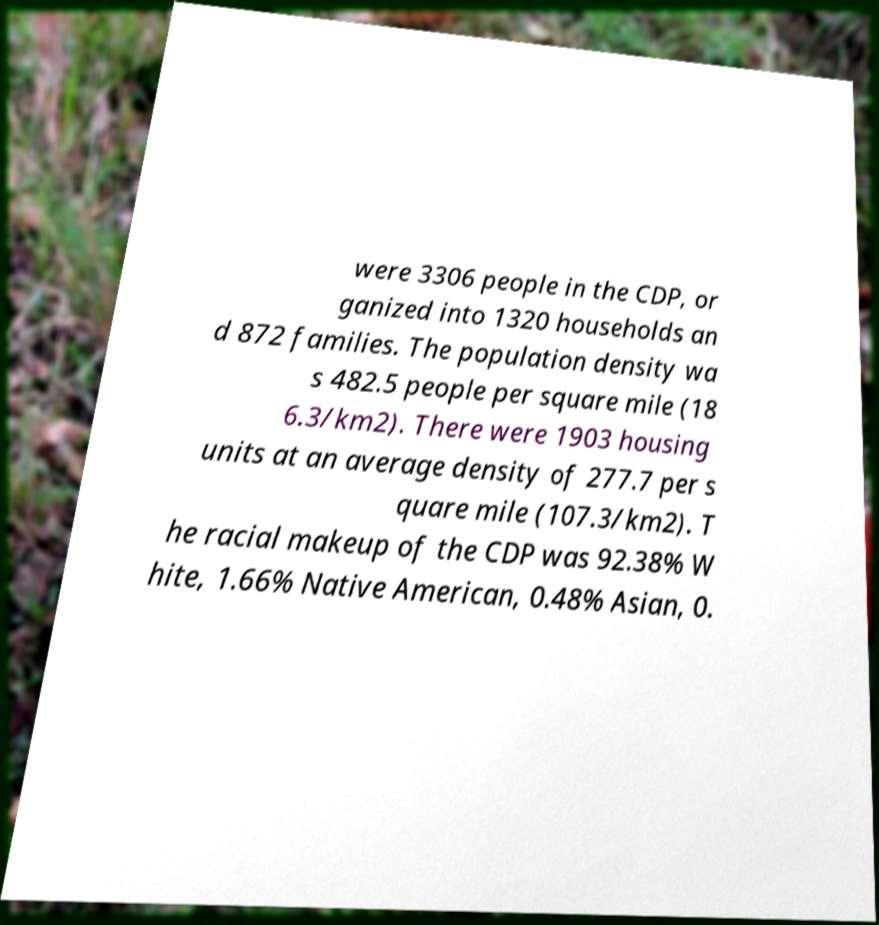For documentation purposes, I need the text within this image transcribed. Could you provide that? were 3306 people in the CDP, or ganized into 1320 households an d 872 families. The population density wa s 482.5 people per square mile (18 6.3/km2). There were 1903 housing units at an average density of 277.7 per s quare mile (107.3/km2). T he racial makeup of the CDP was 92.38% W hite, 1.66% Native American, 0.48% Asian, 0. 